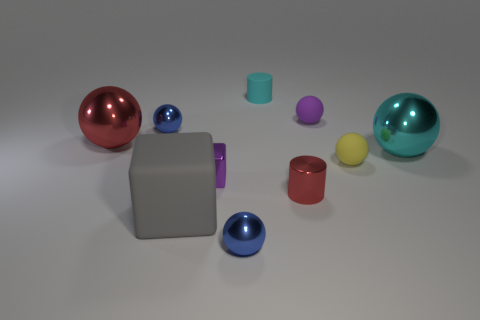How many purple spheres are there?
Offer a terse response. 1. What number of things are tiny purple shiny blocks left of the tiny shiny cylinder or small balls behind the red metallic cylinder?
Ensure brevity in your answer.  4. Is the size of the rubber sphere that is behind the cyan ball the same as the shiny block?
Give a very brief answer. Yes. There is another object that is the same shape as the tiny red metallic thing; what size is it?
Make the answer very short. Small. What material is the purple object that is the same size as the metallic block?
Your response must be concise. Rubber. There is another tiny object that is the same shape as the tiny red thing; what material is it?
Keep it short and to the point. Rubber. How many other objects are there of the same size as the yellow ball?
Make the answer very short. 6. The rubber thing that is the same color as the tiny cube is what size?
Provide a succinct answer. Small. How many metallic balls are the same color as the tiny matte cylinder?
Your answer should be very brief. 1. The tiny cyan matte object has what shape?
Keep it short and to the point. Cylinder. 